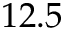<formula> <loc_0><loc_0><loc_500><loc_500>1 2 . 5</formula> 